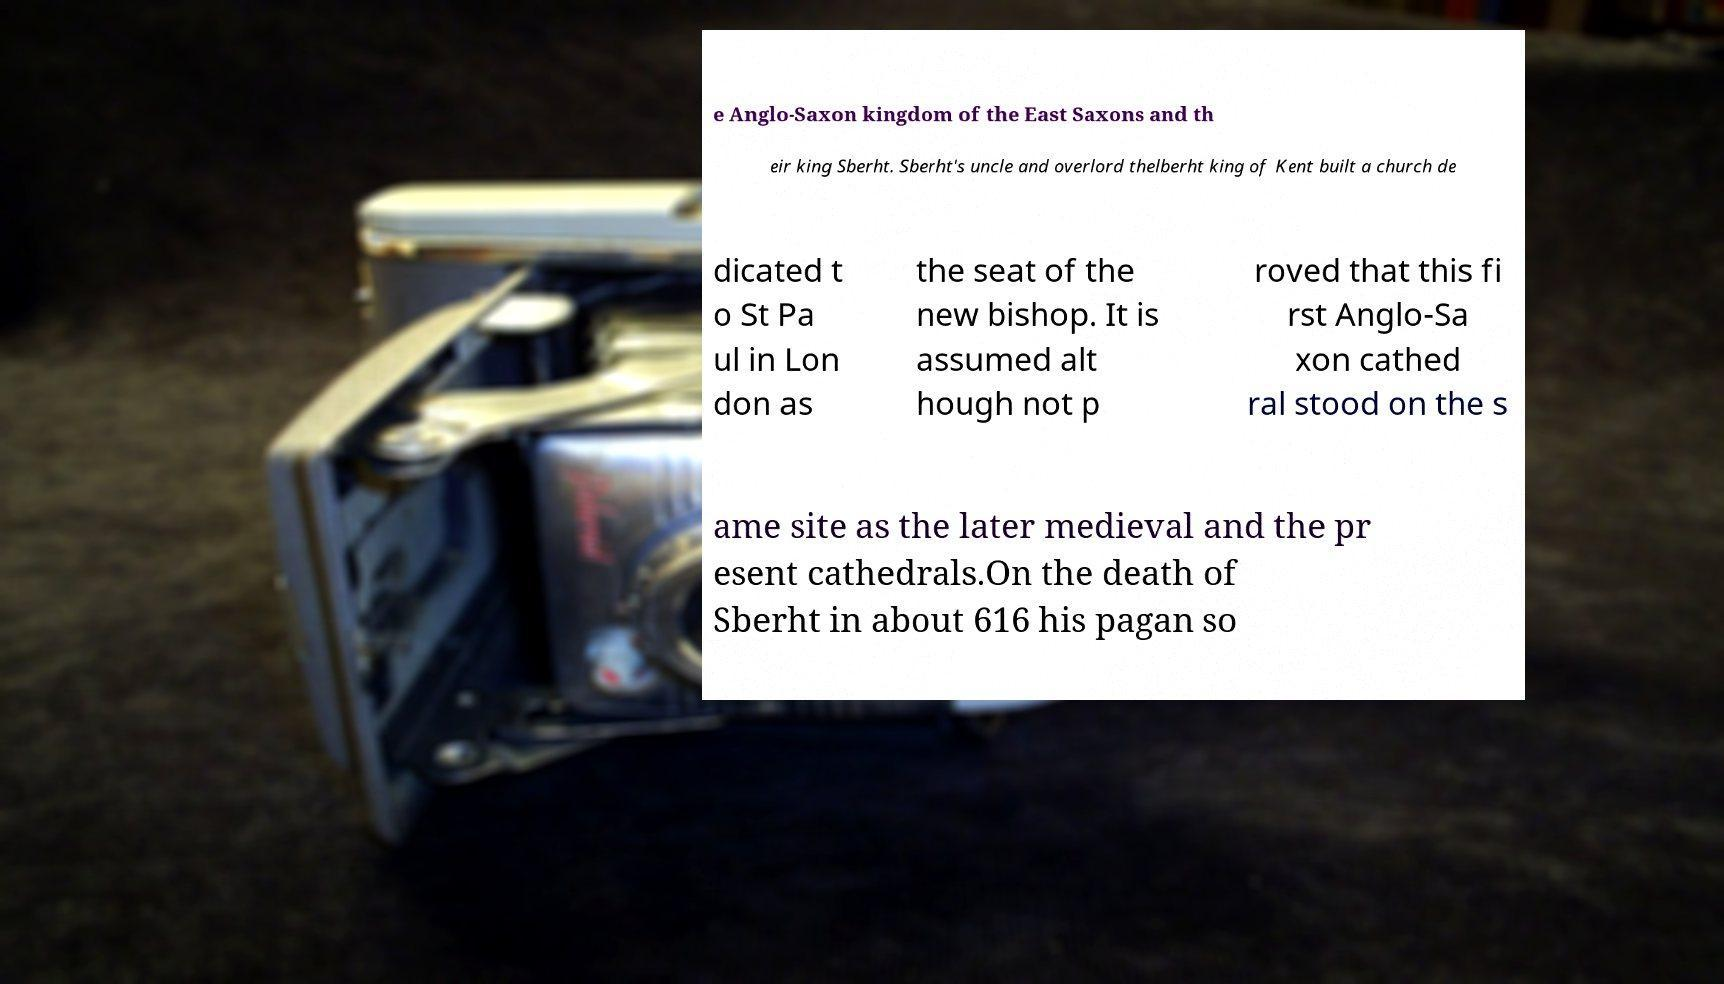There's text embedded in this image that I need extracted. Can you transcribe it verbatim? e Anglo-Saxon kingdom of the East Saxons and th eir king Sberht. Sberht's uncle and overlord thelberht king of Kent built a church de dicated t o St Pa ul in Lon don as the seat of the new bishop. It is assumed alt hough not p roved that this fi rst Anglo-Sa xon cathed ral stood on the s ame site as the later medieval and the pr esent cathedrals.On the death of Sberht in about 616 his pagan so 